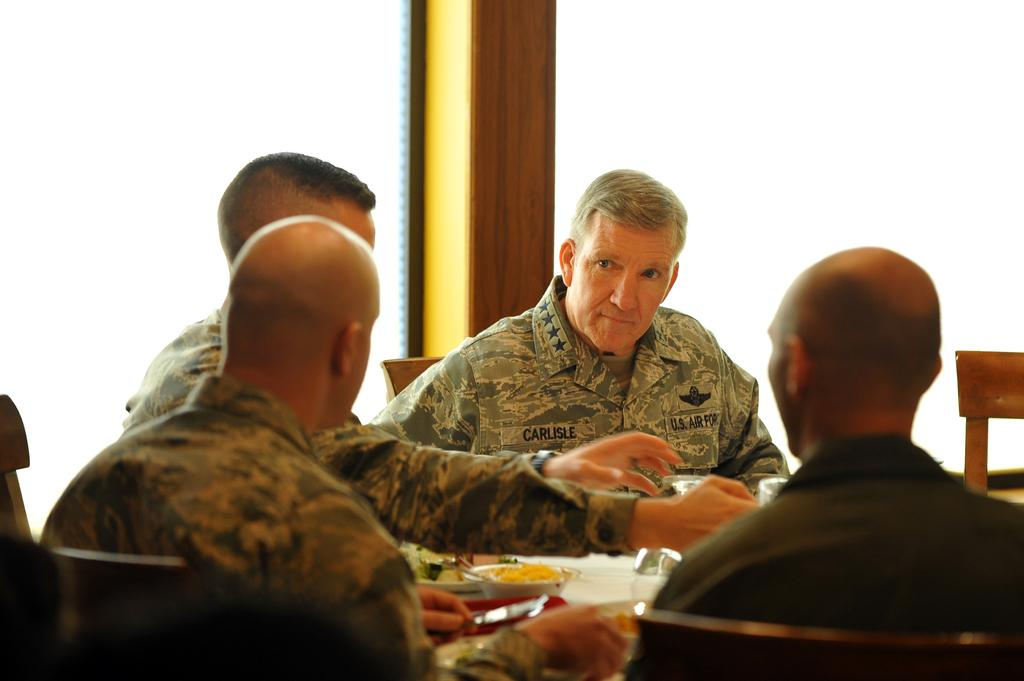What are the people in the image doing? There are people sitting on chairs in the image. What can be seen in the bowl in the image? There are food items in a bowl in the image. How are the men in the image interacting with each other? The men in the image are looking at each other. What type of glue is being used to connect the chin of the person in the image? There is no glue or chin present in the image; it features people sitting on chairs and looking at each other. 